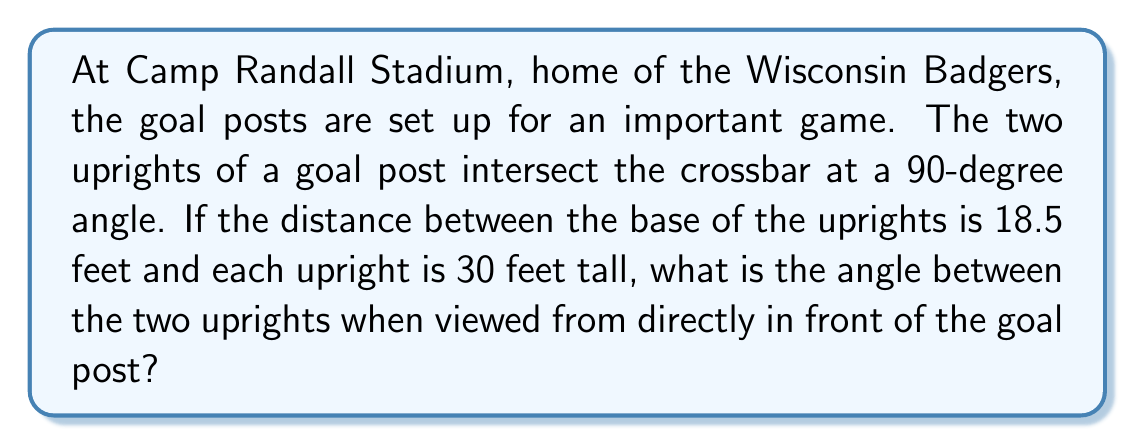Teach me how to tackle this problem. Let's approach this step-by-step:

1) First, we need to visualize the problem. The goal post forms a triangle when viewed from the front, with the crossbar as the base and the two uprights as the sides.

2) We can split this isosceles triangle down the middle, creating two right triangles. Let's focus on one of these right triangles.

3) In this right triangle:
   - The base is half of the distance between the uprights: $18.5/2 = 9.25$ feet
   - The height is the length of the upright: 30 feet

4) We can use the tangent function to find half of the angle we're looking for. Let's call the full angle $\theta$:

   $$\tan(\frac{\theta}{2}) = \frac{\text{opposite}}{\text{adjacent}} = \frac{9.25}{30}$$

5) To solve for $\frac{\theta}{2}$, we take the inverse tangent (arctangent) of both sides:

   $$\frac{\theta}{2} = \arctan(\frac{9.25}{30})$$

6) Using a calculator or computer, we can evaluate this:

   $$\frac{\theta}{2} \approx 0.2996 \text{ radians}$$

7) To get the full angle, we multiply by 2:

   $$\theta \approx 0.2996 * 2 = 0.5992 \text{ radians}$$

8) Convert radians to degrees:

   $$\theta \approx 0.5992 * \frac{180}{\pi} \approx 34.33\text{ degrees}$$

Therefore, the angle between the two uprights is approximately 34.33 degrees.
Answer: $34.33\text{ degrees}$ (or $34.33^\circ$) 